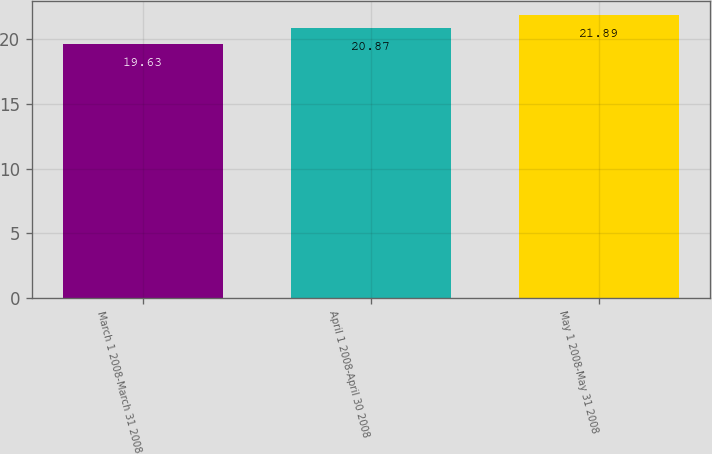Convert chart. <chart><loc_0><loc_0><loc_500><loc_500><bar_chart><fcel>March 1 2008-March 31 2008<fcel>April 1 2008-April 30 2008<fcel>May 1 2008-May 31 2008<nl><fcel>19.63<fcel>20.87<fcel>21.89<nl></chart> 